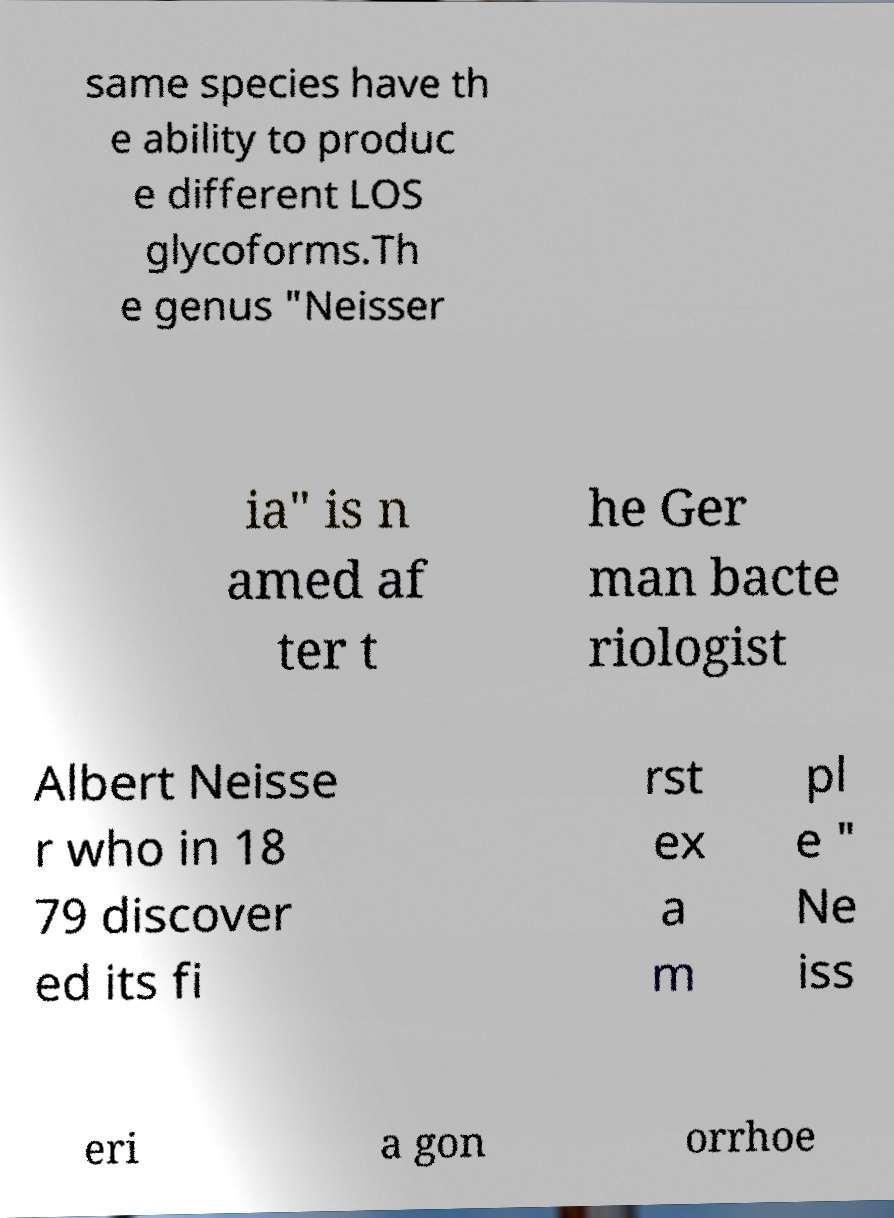Could you extract and type out the text from this image? same species have th e ability to produc e different LOS glycoforms.Th e genus "Neisser ia" is n amed af ter t he Ger man bacte riologist Albert Neisse r who in 18 79 discover ed its fi rst ex a m pl e " Ne iss eri a gon orrhoe 